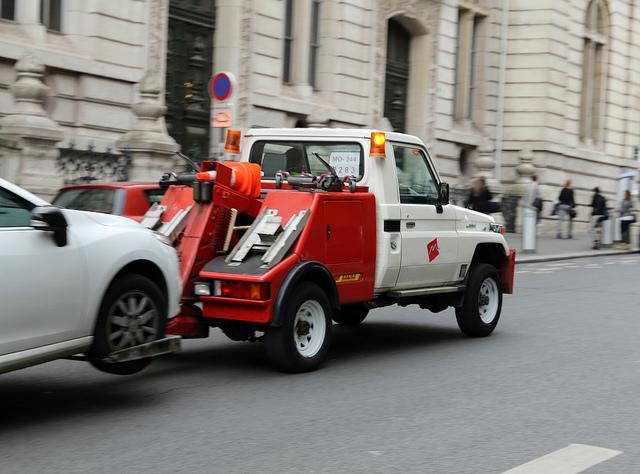How is the car on the back being propelled? tow truck 